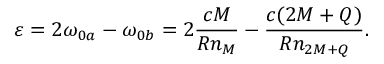Convert formula to latex. <formula><loc_0><loc_0><loc_500><loc_500>\varepsilon = 2 \omega _ { 0 a } - \omega _ { 0 b } = 2 \frac { c M } { R n _ { M } } - \frac { c ( 2 M + Q ) } { R n _ { 2 M + Q } } .</formula> 